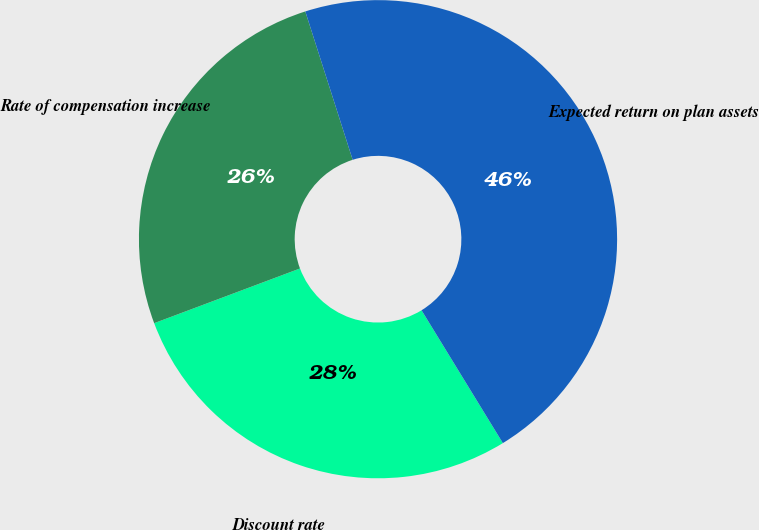Convert chart to OTSL. <chart><loc_0><loc_0><loc_500><loc_500><pie_chart><fcel>Discount rate<fcel>Rate of compensation increase<fcel>Expected return on plan assets<nl><fcel>28.03%<fcel>25.79%<fcel>46.17%<nl></chart> 